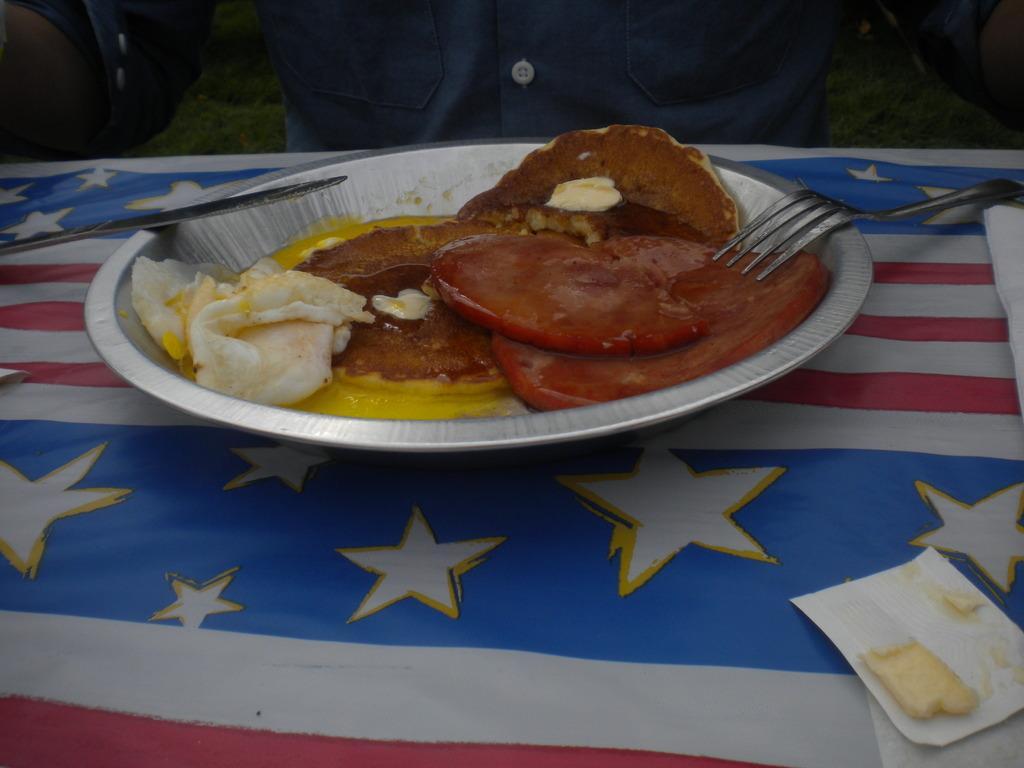Describe this image in one or two sentences. In the picture we can see a table with a flag cloth on it, we can see a plate with some food item and on it we can see a knife and fork and besides the plate we can see a piece of paper with some cream on it and near to the table we can see a person sitting wearing a blue shirt. 